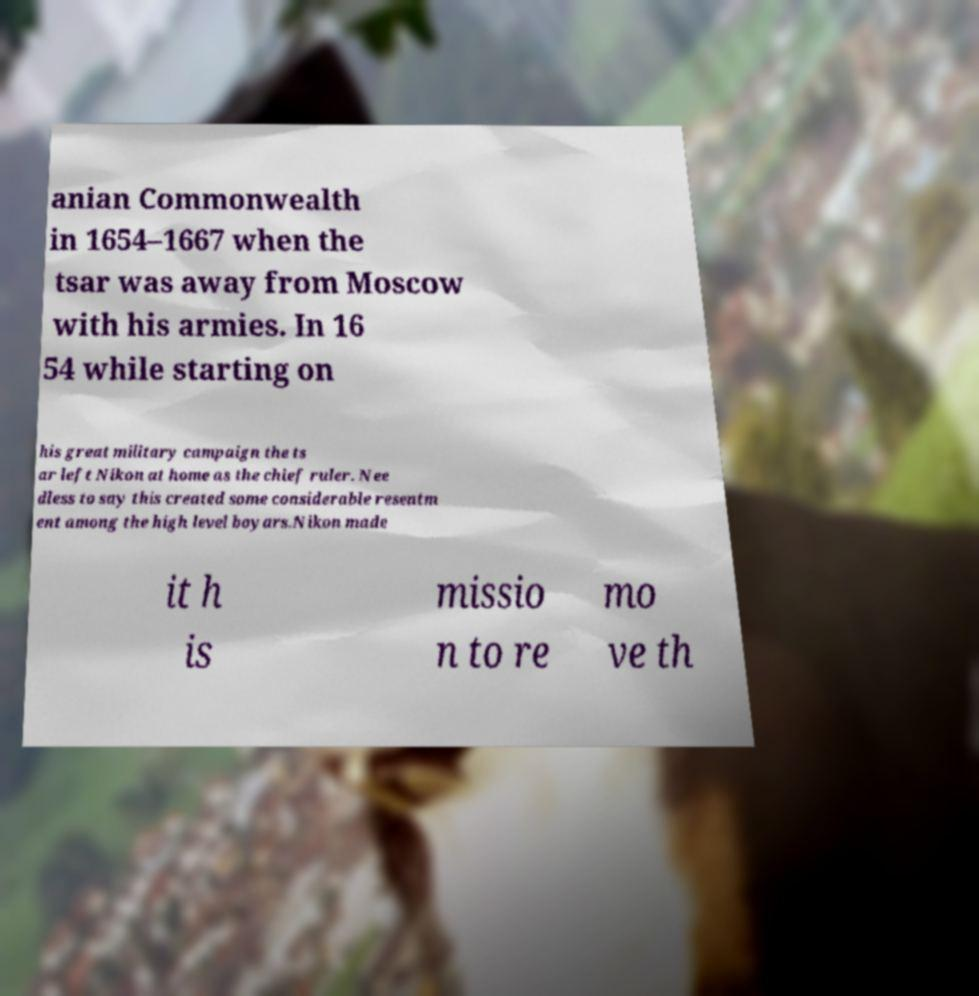What messages or text are displayed in this image? I need them in a readable, typed format. anian Commonwealth in 1654–1667 when the tsar was away from Moscow with his armies. In 16 54 while starting on his great military campaign the ts ar left Nikon at home as the chief ruler. Nee dless to say this created some considerable resentm ent among the high level boyars.Nikon made it h is missio n to re mo ve th 